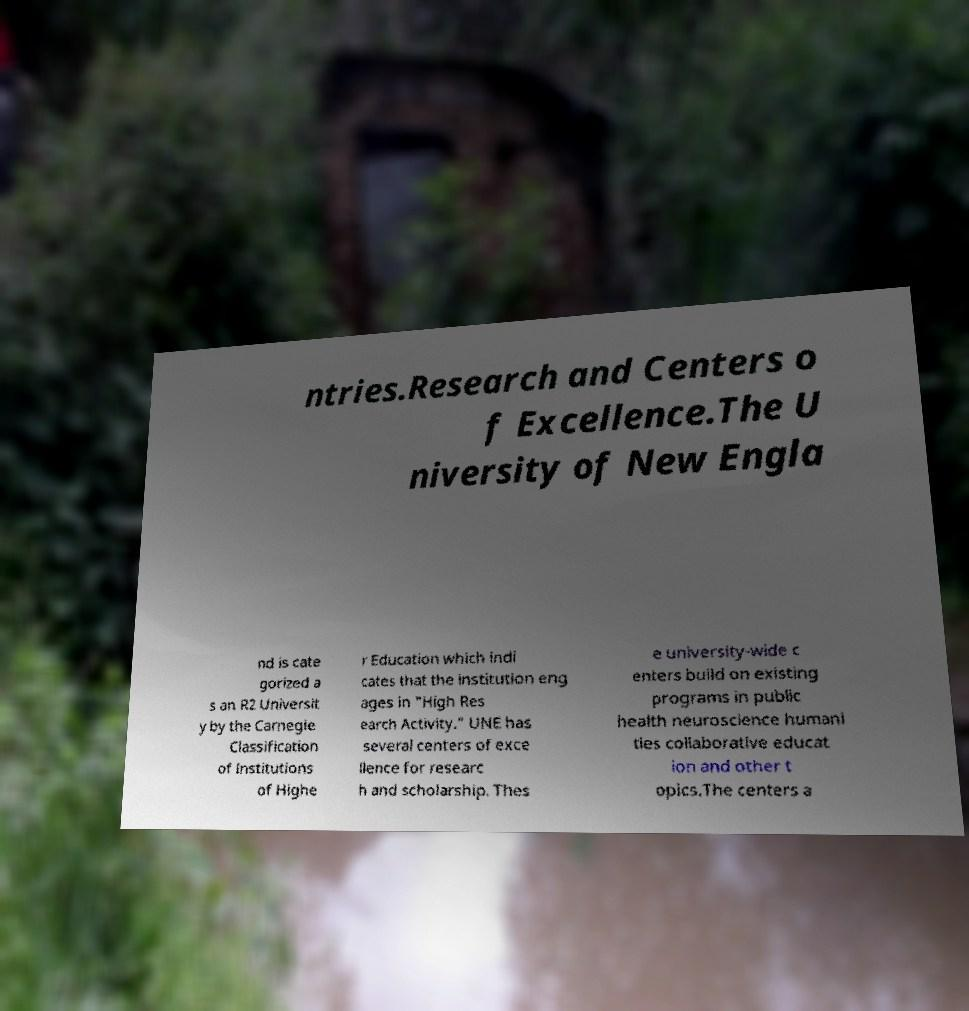I need the written content from this picture converted into text. Can you do that? ntries.Research and Centers o f Excellence.The U niversity of New Engla nd is cate gorized a s an R2 Universit y by the Carnegie Classification of Institutions of Highe r Education which indi cates that the institution eng ages in "High Res earch Activity.” UNE has several centers of exce llence for researc h and scholarship. Thes e university-wide c enters build on existing programs in public health neuroscience humani ties collaborative educat ion and other t opics.The centers a 